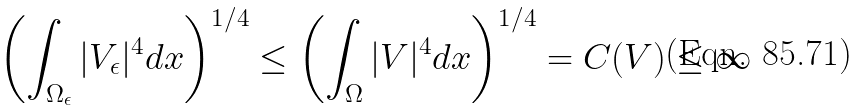Convert formula to latex. <formula><loc_0><loc_0><loc_500><loc_500>\left ( \int _ { \Omega _ { \epsilon } } | V _ { \epsilon } | ^ { 4 } d x \right ) ^ { 1 / 4 } \leq \left ( \int _ { \Omega } | V | ^ { 4 } d x \right ) ^ { 1 / 4 } = C ( V ) \leq \infty</formula> 